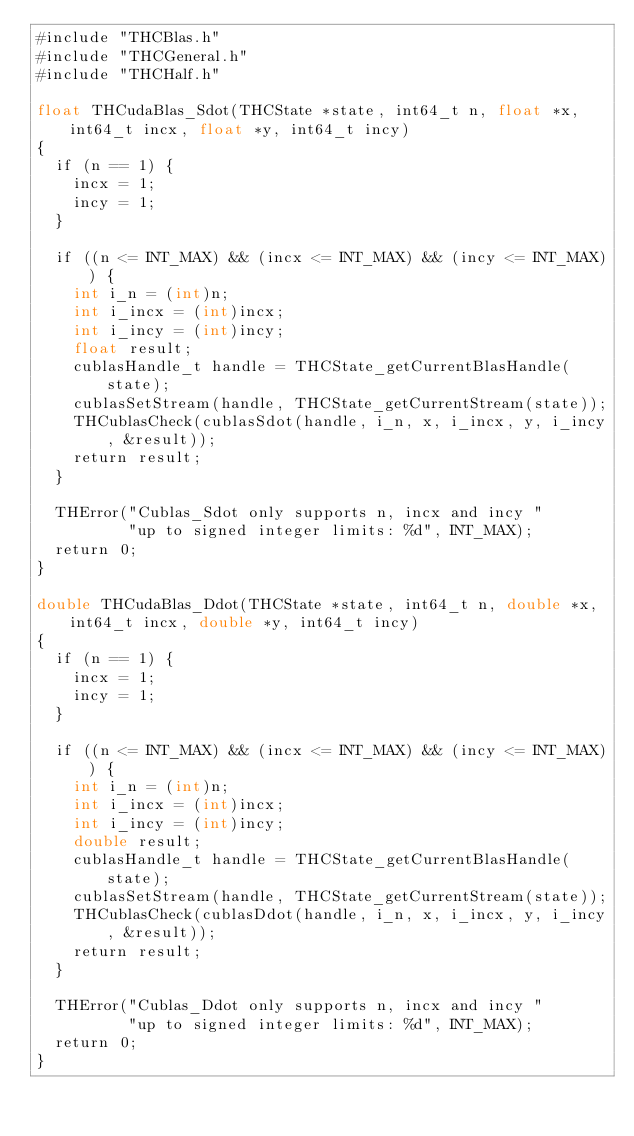<code> <loc_0><loc_0><loc_500><loc_500><_Cuda_>#include "THCBlas.h"
#include "THCGeneral.h"
#include "THCHalf.h"

float THCudaBlas_Sdot(THCState *state, int64_t n, float *x, int64_t incx, float *y, int64_t incy)
{
  if (n == 1) {
    incx = 1;
    incy = 1;
  }

  if ((n <= INT_MAX) && (incx <= INT_MAX) && (incy <= INT_MAX)) {
    int i_n = (int)n;
    int i_incx = (int)incx;
    int i_incy = (int)incy;
    float result;
    cublasHandle_t handle = THCState_getCurrentBlasHandle(state);
    cublasSetStream(handle, THCState_getCurrentStream(state));
    THCublasCheck(cublasSdot(handle, i_n, x, i_incx, y, i_incy, &result));
    return result;
  }

  THError("Cublas_Sdot only supports n, incx and incy "
          "up to signed integer limits: %d", INT_MAX);
  return 0;
}

double THCudaBlas_Ddot(THCState *state, int64_t n, double *x, int64_t incx, double *y, int64_t incy)
{
  if (n == 1) {
    incx = 1;
    incy = 1;
  }

  if ((n <= INT_MAX) && (incx <= INT_MAX) && (incy <= INT_MAX)) {
    int i_n = (int)n;
    int i_incx = (int)incx;
    int i_incy = (int)incy;
    double result;
    cublasHandle_t handle = THCState_getCurrentBlasHandle(state);
    cublasSetStream(handle, THCState_getCurrentStream(state));
    THCublasCheck(cublasDdot(handle, i_n, x, i_incx, y, i_incy, &result));
    return result;
  }

  THError("Cublas_Ddot only supports n, incx and incy "
          "up to signed integer limits: %d", INT_MAX);
  return 0;
}
</code> 